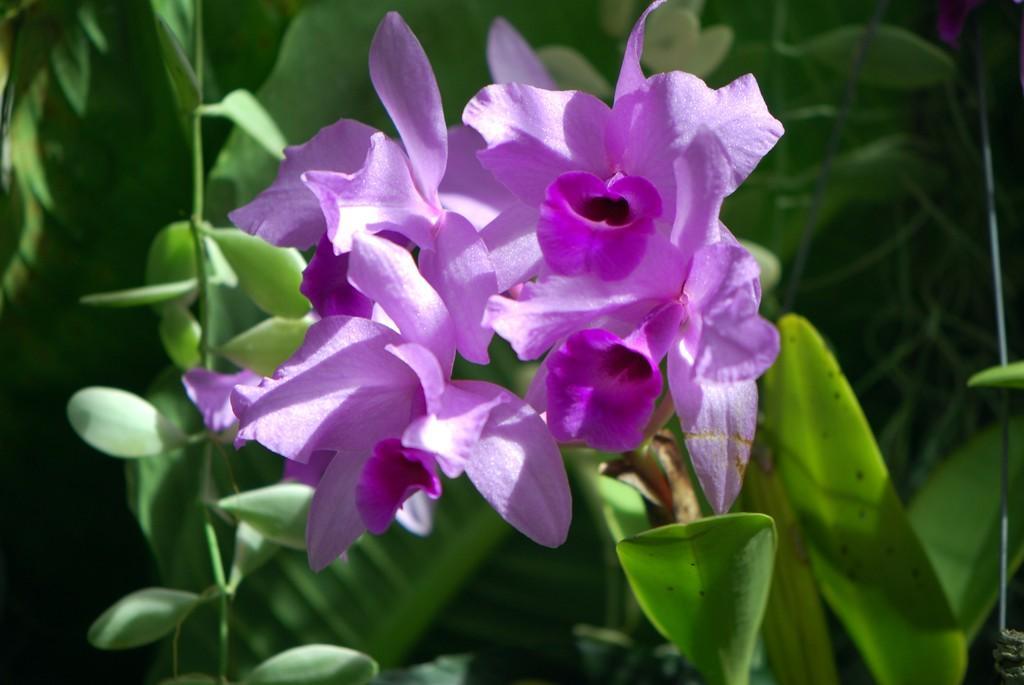In one or two sentences, can you explain what this image depicts? Here we can see a plant with flowers. 